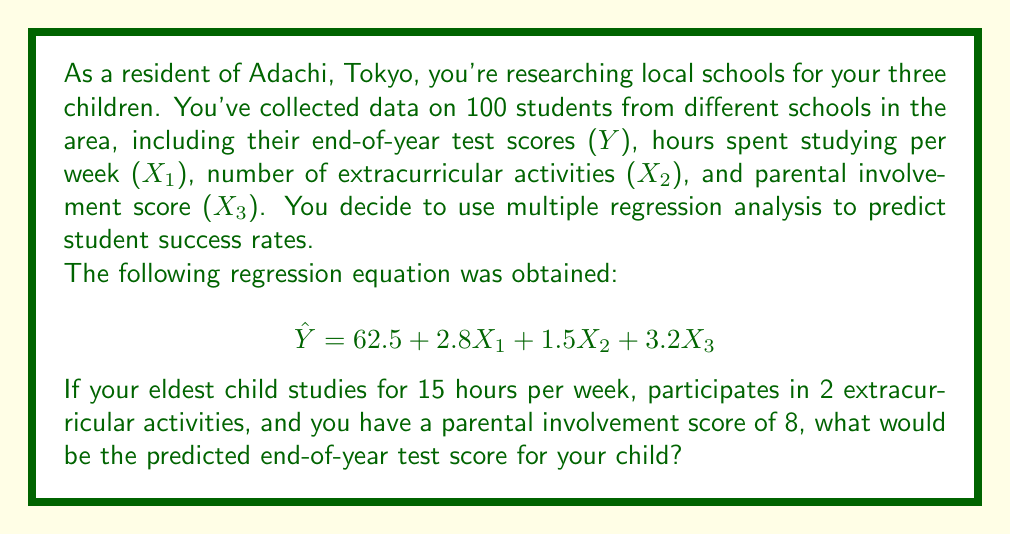Show me your answer to this math problem. To solve this problem, we need to use the given multiple regression equation and substitute the values for each predictor variable:

$$\hat{Y} = 62.5 + 2.8X_1 + 1.5X_2 + 3.2X_3$$

Where:
$\hat{Y}$ = Predicted end-of-year test score
$X_1$ = Hours spent studying per week
$X_2$ = Number of extracurricular activities
$X_3$ = Parental involvement score

Given information:
$X_1 = 15$ (hours studying per week)
$X_2 = 2$ (extracurricular activities)
$X_3 = 8$ (parental involvement score)

Now, let's substitute these values into the equation:

$$\hat{Y} = 62.5 + 2.8(15) + 1.5(2) + 3.2(8)$$

Let's calculate each term:
1. Constant term: $62.5$
2. Study hours term: $2.8 \times 15 = 42$
3. Extracurricular activities term: $1.5 \times 2 = 3$
4. Parental involvement term: $3.2 \times 8 = 25.6$

Now, add all these terms together:

$$\hat{Y} = 62.5 + 42 + 3 + 25.6 = 133.1$$

Therefore, the predicted end-of-year test score for your eldest child is 133.1.
Answer: 133.1 